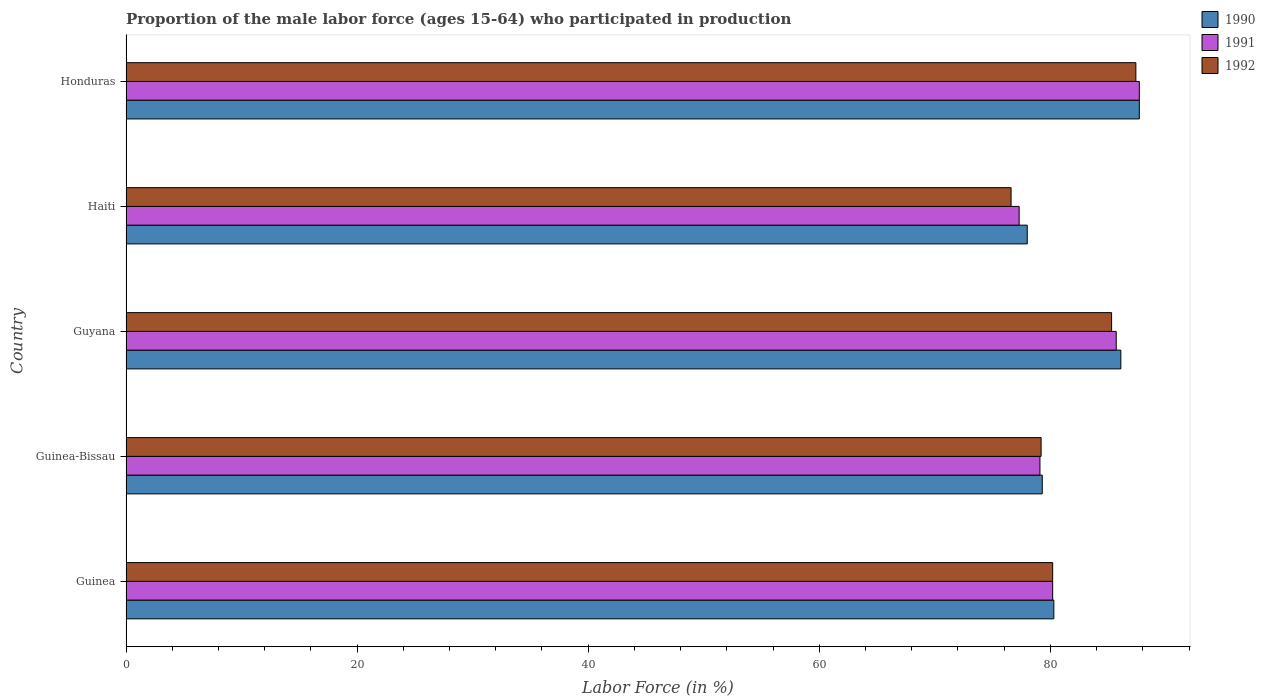How many groups of bars are there?
Provide a short and direct response. 5. Are the number of bars on each tick of the Y-axis equal?
Your response must be concise. Yes. How many bars are there on the 5th tick from the top?
Offer a very short reply. 3. How many bars are there on the 2nd tick from the bottom?
Give a very brief answer. 3. What is the label of the 2nd group of bars from the top?
Your response must be concise. Haiti. In how many cases, is the number of bars for a given country not equal to the number of legend labels?
Your answer should be very brief. 0. What is the proportion of the male labor force who participated in production in 1992 in Guyana?
Provide a succinct answer. 85.3. Across all countries, what is the maximum proportion of the male labor force who participated in production in 1992?
Make the answer very short. 87.4. In which country was the proportion of the male labor force who participated in production in 1990 maximum?
Provide a short and direct response. Honduras. In which country was the proportion of the male labor force who participated in production in 1992 minimum?
Give a very brief answer. Haiti. What is the total proportion of the male labor force who participated in production in 1992 in the graph?
Provide a short and direct response. 408.7. What is the difference between the proportion of the male labor force who participated in production in 1992 in Haiti and that in Honduras?
Your answer should be compact. -10.8. What is the difference between the proportion of the male labor force who participated in production in 1992 in Honduras and the proportion of the male labor force who participated in production in 1991 in Guinea-Bissau?
Offer a very short reply. 8.3. What is the average proportion of the male labor force who participated in production in 1991 per country?
Your answer should be compact. 82. What is the difference between the proportion of the male labor force who participated in production in 1992 and proportion of the male labor force who participated in production in 1990 in Honduras?
Offer a very short reply. -0.3. In how many countries, is the proportion of the male labor force who participated in production in 1991 greater than 44 %?
Offer a terse response. 5. What is the ratio of the proportion of the male labor force who participated in production in 1991 in Guinea to that in Guinea-Bissau?
Provide a succinct answer. 1.01. Is the proportion of the male labor force who participated in production in 1990 in Guinea-Bissau less than that in Haiti?
Your response must be concise. No. Is the difference between the proportion of the male labor force who participated in production in 1992 in Guinea-Bissau and Haiti greater than the difference between the proportion of the male labor force who participated in production in 1990 in Guinea-Bissau and Haiti?
Keep it short and to the point. Yes. What is the difference between the highest and the second highest proportion of the male labor force who participated in production in 1990?
Your answer should be compact. 1.6. What is the difference between the highest and the lowest proportion of the male labor force who participated in production in 1992?
Keep it short and to the point. 10.8. In how many countries, is the proportion of the male labor force who participated in production in 1992 greater than the average proportion of the male labor force who participated in production in 1992 taken over all countries?
Your answer should be compact. 2. What does the 2nd bar from the bottom in Haiti represents?
Provide a succinct answer. 1991. How many countries are there in the graph?
Your answer should be very brief. 5. Does the graph contain grids?
Offer a terse response. No. Where does the legend appear in the graph?
Offer a very short reply. Top right. How are the legend labels stacked?
Your answer should be very brief. Vertical. What is the title of the graph?
Your answer should be very brief. Proportion of the male labor force (ages 15-64) who participated in production. Does "1993" appear as one of the legend labels in the graph?
Offer a terse response. No. What is the label or title of the Y-axis?
Your answer should be very brief. Country. What is the Labor Force (in %) of 1990 in Guinea?
Make the answer very short. 80.3. What is the Labor Force (in %) in 1991 in Guinea?
Give a very brief answer. 80.2. What is the Labor Force (in %) of 1992 in Guinea?
Your answer should be very brief. 80.2. What is the Labor Force (in %) in 1990 in Guinea-Bissau?
Give a very brief answer. 79.3. What is the Labor Force (in %) in 1991 in Guinea-Bissau?
Your answer should be very brief. 79.1. What is the Labor Force (in %) in 1992 in Guinea-Bissau?
Provide a short and direct response. 79.2. What is the Labor Force (in %) of 1990 in Guyana?
Provide a short and direct response. 86.1. What is the Labor Force (in %) of 1991 in Guyana?
Keep it short and to the point. 85.7. What is the Labor Force (in %) in 1992 in Guyana?
Offer a very short reply. 85.3. What is the Labor Force (in %) of 1991 in Haiti?
Your answer should be compact. 77.3. What is the Labor Force (in %) of 1992 in Haiti?
Your response must be concise. 76.6. What is the Labor Force (in %) of 1990 in Honduras?
Provide a short and direct response. 87.7. What is the Labor Force (in %) of 1991 in Honduras?
Provide a short and direct response. 87.7. What is the Labor Force (in %) of 1992 in Honduras?
Provide a succinct answer. 87.4. Across all countries, what is the maximum Labor Force (in %) in 1990?
Your response must be concise. 87.7. Across all countries, what is the maximum Labor Force (in %) in 1991?
Offer a very short reply. 87.7. Across all countries, what is the maximum Labor Force (in %) in 1992?
Your answer should be very brief. 87.4. Across all countries, what is the minimum Labor Force (in %) in 1990?
Give a very brief answer. 78. Across all countries, what is the minimum Labor Force (in %) in 1991?
Ensure brevity in your answer.  77.3. Across all countries, what is the minimum Labor Force (in %) of 1992?
Your response must be concise. 76.6. What is the total Labor Force (in %) of 1990 in the graph?
Provide a succinct answer. 411.4. What is the total Labor Force (in %) in 1991 in the graph?
Your answer should be compact. 410. What is the total Labor Force (in %) of 1992 in the graph?
Your answer should be very brief. 408.7. What is the difference between the Labor Force (in %) of 1990 in Guinea and that in Guinea-Bissau?
Ensure brevity in your answer.  1. What is the difference between the Labor Force (in %) of 1990 in Guinea and that in Guyana?
Offer a terse response. -5.8. What is the difference between the Labor Force (in %) in 1992 in Guinea and that in Guyana?
Provide a short and direct response. -5.1. What is the difference between the Labor Force (in %) in 1990 in Guinea and that in Honduras?
Offer a terse response. -7.4. What is the difference between the Labor Force (in %) in 1992 in Guinea and that in Honduras?
Your response must be concise. -7.2. What is the difference between the Labor Force (in %) of 1990 in Guinea-Bissau and that in Guyana?
Keep it short and to the point. -6.8. What is the difference between the Labor Force (in %) in 1991 in Guinea-Bissau and that in Guyana?
Offer a terse response. -6.6. What is the difference between the Labor Force (in %) in 1990 in Guinea-Bissau and that in Haiti?
Your answer should be compact. 1.3. What is the difference between the Labor Force (in %) in 1992 in Guinea-Bissau and that in Honduras?
Make the answer very short. -8.2. What is the difference between the Labor Force (in %) of 1990 in Guyana and that in Haiti?
Make the answer very short. 8.1. What is the difference between the Labor Force (in %) in 1991 in Guyana and that in Haiti?
Your answer should be compact. 8.4. What is the difference between the Labor Force (in %) of 1992 in Guyana and that in Honduras?
Ensure brevity in your answer.  -2.1. What is the difference between the Labor Force (in %) of 1992 in Haiti and that in Honduras?
Offer a terse response. -10.8. What is the difference between the Labor Force (in %) of 1990 in Guinea and the Labor Force (in %) of 1991 in Guinea-Bissau?
Give a very brief answer. 1.2. What is the difference between the Labor Force (in %) of 1990 in Guinea and the Labor Force (in %) of 1992 in Guinea-Bissau?
Your response must be concise. 1.1. What is the difference between the Labor Force (in %) of 1991 in Guinea and the Labor Force (in %) of 1992 in Guinea-Bissau?
Your answer should be compact. 1. What is the difference between the Labor Force (in %) in 1990 in Guinea and the Labor Force (in %) in 1991 in Haiti?
Your response must be concise. 3. What is the difference between the Labor Force (in %) in 1990 in Guinea and the Labor Force (in %) in 1992 in Honduras?
Offer a very short reply. -7.1. What is the difference between the Labor Force (in %) in 1991 in Guinea and the Labor Force (in %) in 1992 in Honduras?
Provide a succinct answer. -7.2. What is the difference between the Labor Force (in %) of 1990 in Guinea-Bissau and the Labor Force (in %) of 1992 in Guyana?
Provide a short and direct response. -6. What is the difference between the Labor Force (in %) in 1991 in Guinea-Bissau and the Labor Force (in %) in 1992 in Guyana?
Give a very brief answer. -6.2. What is the difference between the Labor Force (in %) in 1991 in Guinea-Bissau and the Labor Force (in %) in 1992 in Haiti?
Ensure brevity in your answer.  2.5. What is the difference between the Labor Force (in %) in 1990 in Guinea-Bissau and the Labor Force (in %) in 1991 in Honduras?
Give a very brief answer. -8.4. What is the difference between the Labor Force (in %) of 1990 in Guinea-Bissau and the Labor Force (in %) of 1992 in Honduras?
Offer a terse response. -8.1. What is the difference between the Labor Force (in %) in 1991 in Guinea-Bissau and the Labor Force (in %) in 1992 in Honduras?
Provide a short and direct response. -8.3. What is the difference between the Labor Force (in %) of 1990 in Guyana and the Labor Force (in %) of 1991 in Haiti?
Provide a succinct answer. 8.8. What is the difference between the Labor Force (in %) in 1990 in Guyana and the Labor Force (in %) in 1992 in Haiti?
Keep it short and to the point. 9.5. What is the difference between the Labor Force (in %) of 1991 in Guyana and the Labor Force (in %) of 1992 in Honduras?
Offer a very short reply. -1.7. What is the difference between the Labor Force (in %) of 1991 in Haiti and the Labor Force (in %) of 1992 in Honduras?
Make the answer very short. -10.1. What is the average Labor Force (in %) of 1990 per country?
Give a very brief answer. 82.28. What is the average Labor Force (in %) of 1992 per country?
Your answer should be compact. 81.74. What is the difference between the Labor Force (in %) in 1990 and Labor Force (in %) in 1991 in Guinea?
Your answer should be compact. 0.1. What is the difference between the Labor Force (in %) of 1990 and Labor Force (in %) of 1992 in Guinea?
Give a very brief answer. 0.1. What is the difference between the Labor Force (in %) of 1991 and Labor Force (in %) of 1992 in Guinea?
Ensure brevity in your answer.  0. What is the difference between the Labor Force (in %) of 1991 and Labor Force (in %) of 1992 in Guinea-Bissau?
Provide a succinct answer. -0.1. What is the difference between the Labor Force (in %) of 1990 and Labor Force (in %) of 1991 in Guyana?
Give a very brief answer. 0.4. What is the difference between the Labor Force (in %) in 1990 and Labor Force (in %) in 1992 in Guyana?
Provide a short and direct response. 0.8. What is the difference between the Labor Force (in %) in 1991 and Labor Force (in %) in 1992 in Guyana?
Your answer should be very brief. 0.4. What is the difference between the Labor Force (in %) in 1990 and Labor Force (in %) in 1991 in Haiti?
Your answer should be compact. 0.7. What is the difference between the Labor Force (in %) of 1990 and Labor Force (in %) of 1992 in Haiti?
Your answer should be very brief. 1.4. What is the difference between the Labor Force (in %) of 1991 and Labor Force (in %) of 1992 in Haiti?
Your answer should be compact. 0.7. What is the difference between the Labor Force (in %) of 1990 and Labor Force (in %) of 1992 in Honduras?
Give a very brief answer. 0.3. What is the difference between the Labor Force (in %) in 1991 and Labor Force (in %) in 1992 in Honduras?
Your response must be concise. 0.3. What is the ratio of the Labor Force (in %) in 1990 in Guinea to that in Guinea-Bissau?
Make the answer very short. 1.01. What is the ratio of the Labor Force (in %) in 1991 in Guinea to that in Guinea-Bissau?
Offer a terse response. 1.01. What is the ratio of the Labor Force (in %) in 1992 in Guinea to that in Guinea-Bissau?
Keep it short and to the point. 1.01. What is the ratio of the Labor Force (in %) of 1990 in Guinea to that in Guyana?
Provide a short and direct response. 0.93. What is the ratio of the Labor Force (in %) of 1991 in Guinea to that in Guyana?
Your response must be concise. 0.94. What is the ratio of the Labor Force (in %) of 1992 in Guinea to that in Guyana?
Give a very brief answer. 0.94. What is the ratio of the Labor Force (in %) in 1990 in Guinea to that in Haiti?
Your answer should be compact. 1.03. What is the ratio of the Labor Force (in %) of 1991 in Guinea to that in Haiti?
Offer a very short reply. 1.04. What is the ratio of the Labor Force (in %) of 1992 in Guinea to that in Haiti?
Keep it short and to the point. 1.05. What is the ratio of the Labor Force (in %) in 1990 in Guinea to that in Honduras?
Your answer should be very brief. 0.92. What is the ratio of the Labor Force (in %) of 1991 in Guinea to that in Honduras?
Ensure brevity in your answer.  0.91. What is the ratio of the Labor Force (in %) in 1992 in Guinea to that in Honduras?
Give a very brief answer. 0.92. What is the ratio of the Labor Force (in %) of 1990 in Guinea-Bissau to that in Guyana?
Offer a very short reply. 0.92. What is the ratio of the Labor Force (in %) of 1991 in Guinea-Bissau to that in Guyana?
Keep it short and to the point. 0.92. What is the ratio of the Labor Force (in %) in 1992 in Guinea-Bissau to that in Guyana?
Give a very brief answer. 0.93. What is the ratio of the Labor Force (in %) in 1990 in Guinea-Bissau to that in Haiti?
Offer a terse response. 1.02. What is the ratio of the Labor Force (in %) in 1991 in Guinea-Bissau to that in Haiti?
Your answer should be compact. 1.02. What is the ratio of the Labor Force (in %) in 1992 in Guinea-Bissau to that in Haiti?
Your answer should be compact. 1.03. What is the ratio of the Labor Force (in %) in 1990 in Guinea-Bissau to that in Honduras?
Provide a short and direct response. 0.9. What is the ratio of the Labor Force (in %) of 1991 in Guinea-Bissau to that in Honduras?
Provide a short and direct response. 0.9. What is the ratio of the Labor Force (in %) of 1992 in Guinea-Bissau to that in Honduras?
Keep it short and to the point. 0.91. What is the ratio of the Labor Force (in %) of 1990 in Guyana to that in Haiti?
Your answer should be very brief. 1.1. What is the ratio of the Labor Force (in %) of 1991 in Guyana to that in Haiti?
Keep it short and to the point. 1.11. What is the ratio of the Labor Force (in %) of 1992 in Guyana to that in Haiti?
Make the answer very short. 1.11. What is the ratio of the Labor Force (in %) of 1990 in Guyana to that in Honduras?
Your answer should be compact. 0.98. What is the ratio of the Labor Force (in %) of 1991 in Guyana to that in Honduras?
Offer a terse response. 0.98. What is the ratio of the Labor Force (in %) in 1992 in Guyana to that in Honduras?
Ensure brevity in your answer.  0.98. What is the ratio of the Labor Force (in %) in 1990 in Haiti to that in Honduras?
Offer a very short reply. 0.89. What is the ratio of the Labor Force (in %) of 1991 in Haiti to that in Honduras?
Offer a very short reply. 0.88. What is the ratio of the Labor Force (in %) of 1992 in Haiti to that in Honduras?
Your answer should be compact. 0.88. What is the difference between the highest and the second highest Labor Force (in %) of 1990?
Your response must be concise. 1.6. What is the difference between the highest and the second highest Labor Force (in %) in 1991?
Your response must be concise. 2. What is the difference between the highest and the lowest Labor Force (in %) in 1990?
Your answer should be very brief. 9.7. What is the difference between the highest and the lowest Labor Force (in %) in 1991?
Your answer should be compact. 10.4. What is the difference between the highest and the lowest Labor Force (in %) of 1992?
Provide a short and direct response. 10.8. 